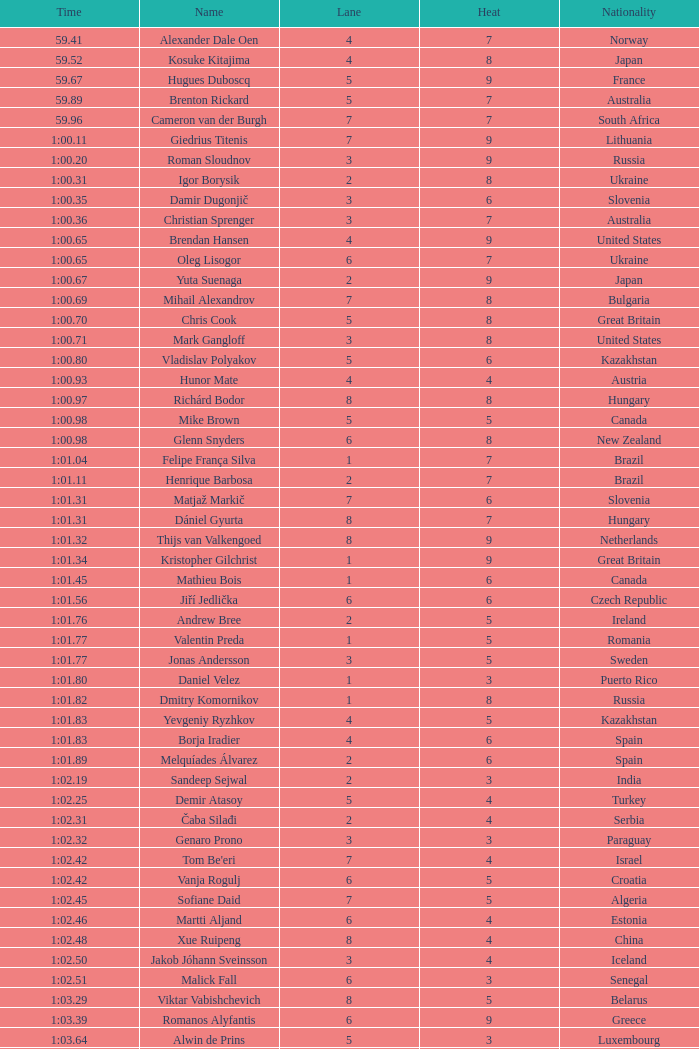What is the smallest lane number of Xue Ruipeng? 8.0. 